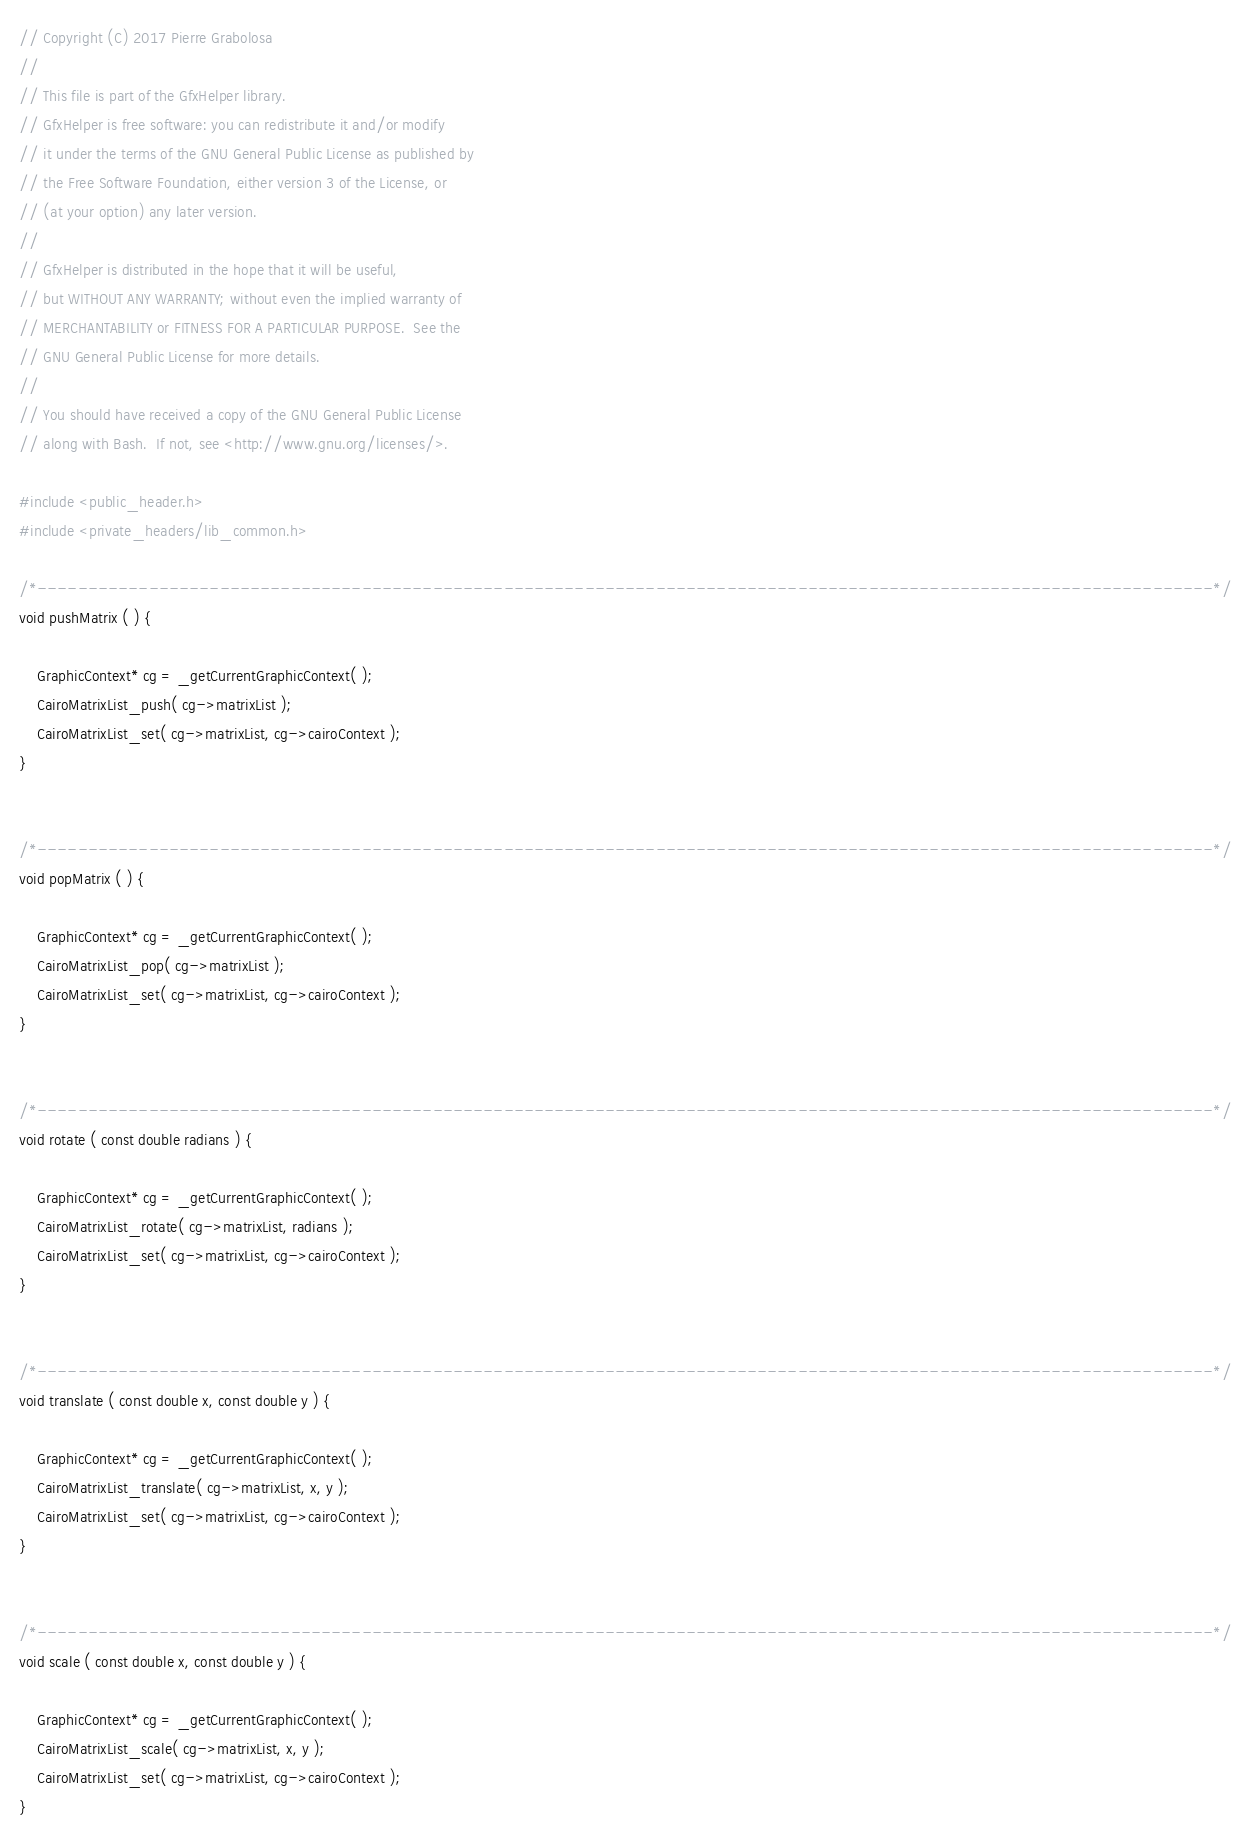Convert code to text. <code><loc_0><loc_0><loc_500><loc_500><_C_>// Copyright (C) 2017 Pierre Grabolosa
// 
// This file is part of the GfxHelper library.
// GfxHelper is free software: you can redistribute it and/or modify
// it under the terms of the GNU General Public License as published by
// the Free Software Foundation, either version 3 of the License, or
// (at your option) any later version.
// 
// GfxHelper is distributed in the hope that it will be useful,
// but WITHOUT ANY WARRANTY; without even the implied warranty of
// MERCHANTABILITY or FITNESS FOR A PARTICULAR PURPOSE.  See the
// GNU General Public License for more details.
// 
// You should have received a copy of the GNU General Public License
// along with Bash.  If not, see <http://www.gnu.org/licenses/>.

#include <public_header.h>
#include <private_headers/lib_common.h>

/*--------------------------------------------------------------------------------------------------------------------*/
void pushMatrix ( ) {
	
	GraphicContext* cg = _getCurrentGraphicContext( );
	CairoMatrixList_push( cg->matrixList );
	CairoMatrixList_set( cg->matrixList, cg->cairoContext );
}


/*--------------------------------------------------------------------------------------------------------------------*/
void popMatrix ( ) {
	
	GraphicContext* cg = _getCurrentGraphicContext( );
	CairoMatrixList_pop( cg->matrixList );
	CairoMatrixList_set( cg->matrixList, cg->cairoContext );
}


/*--------------------------------------------------------------------------------------------------------------------*/
void rotate ( const double radians ) {
	
	GraphicContext* cg = _getCurrentGraphicContext( );
	CairoMatrixList_rotate( cg->matrixList, radians );
	CairoMatrixList_set( cg->matrixList, cg->cairoContext );
}


/*--------------------------------------------------------------------------------------------------------------------*/
void translate ( const double x, const double y ) {
	
	GraphicContext* cg = _getCurrentGraphicContext( );
	CairoMatrixList_translate( cg->matrixList, x, y );
	CairoMatrixList_set( cg->matrixList, cg->cairoContext );
}


/*--------------------------------------------------------------------------------------------------------------------*/
void scale ( const double x, const double y ) {
	
	GraphicContext* cg = _getCurrentGraphicContext( );
	CairoMatrixList_scale( cg->matrixList, x, y );
	CairoMatrixList_set( cg->matrixList, cg->cairoContext );
}</code> 